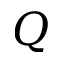Convert formula to latex. <formula><loc_0><loc_0><loc_500><loc_500>Q</formula> 